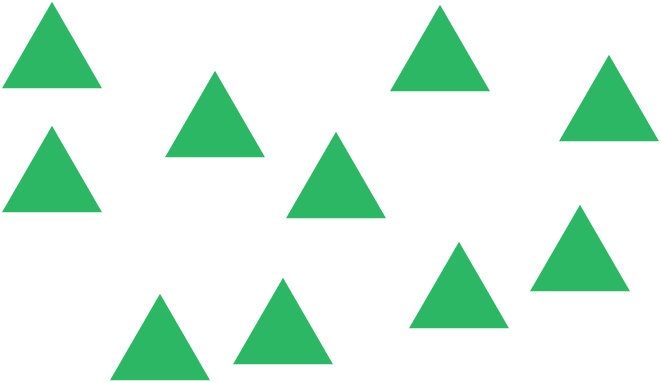I have a question about what is happening in this picture, can you please give me an answer?

How many triangles are there? To determine the number of triangles in the image, one would count each individual triangle. Upon close inspection, I count a total of ten triangles. There is no indication of partial triangles or those that might be hidden or only partially visible, which simplifies the counting process. It's important to carefully scan the entire image to ensure no triangles are overlooked, but based on what is visible, the answer is ten triangles. 